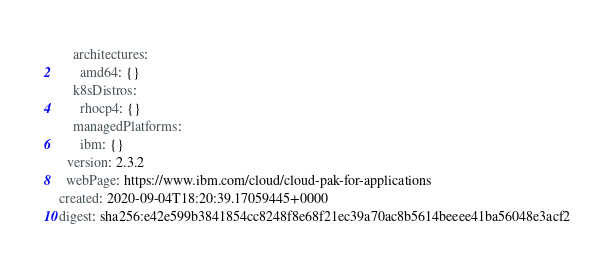<code> <loc_0><loc_0><loc_500><loc_500><_YAML_>    architectures:
      amd64: {}
    k8sDistros:
      rhocp4: {}
    managedPlatforms:
      ibm: {}
  version: 2.3.2
  webPage: https://www.ibm.com/cloud/cloud-pak-for-applications
created: 2020-09-04T18:20:39.17059445+0000
digest: sha256:e42e599b3841854cc8248f8e68f21ec39a70ac8b5614beeee41ba56048e3acf2
</code> 